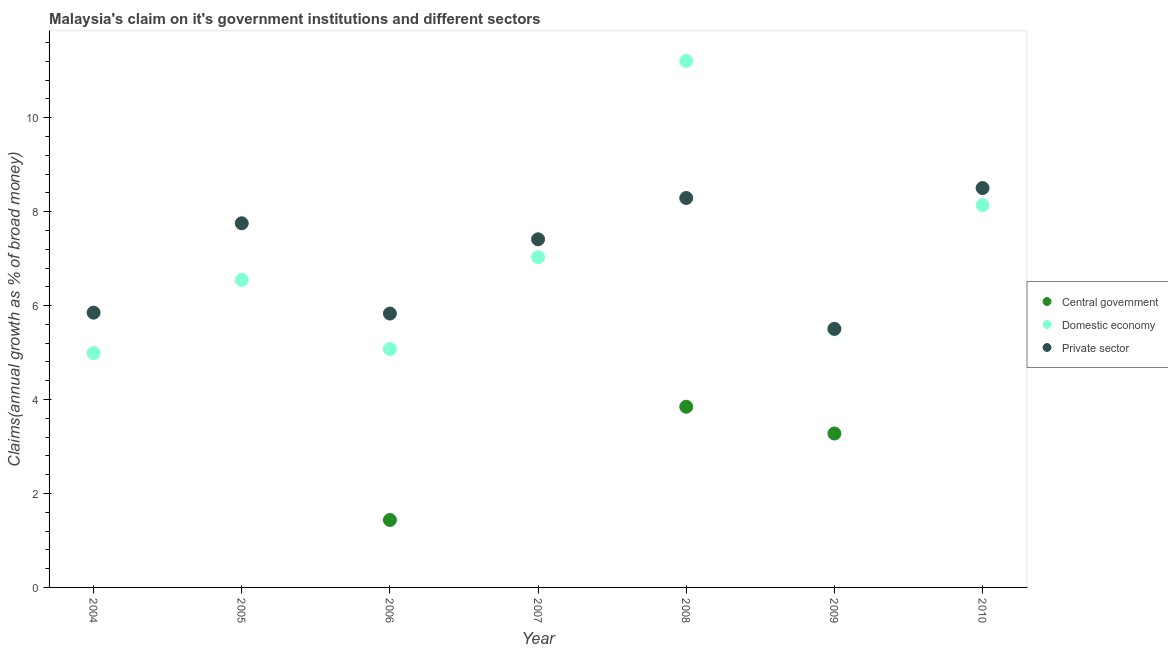How many different coloured dotlines are there?
Make the answer very short. 3. What is the percentage of claim on the central government in 2006?
Provide a short and direct response. 1.44. Across all years, what is the maximum percentage of claim on the domestic economy?
Ensure brevity in your answer.  11.21. Across all years, what is the minimum percentage of claim on the domestic economy?
Offer a terse response. 4.99. In which year was the percentage of claim on the private sector maximum?
Give a very brief answer. 2010. What is the total percentage of claim on the domestic economy in the graph?
Offer a very short reply. 48.48. What is the difference between the percentage of claim on the domestic economy in 2004 and that in 2006?
Give a very brief answer. -0.09. What is the difference between the percentage of claim on the central government in 2010 and the percentage of claim on the private sector in 2006?
Ensure brevity in your answer.  -5.83. What is the average percentage of claim on the central government per year?
Provide a short and direct response. 1.22. In the year 2006, what is the difference between the percentage of claim on the private sector and percentage of claim on the domestic economy?
Provide a succinct answer. 0.76. In how many years, is the percentage of claim on the private sector greater than 4.8 %?
Offer a terse response. 7. What is the ratio of the percentage of claim on the private sector in 2006 to that in 2008?
Offer a terse response. 0.7. What is the difference between the highest and the second highest percentage of claim on the private sector?
Make the answer very short. 0.21. What is the difference between the highest and the lowest percentage of claim on the private sector?
Give a very brief answer. 3. How many dotlines are there?
Your answer should be compact. 3. Does the graph contain grids?
Provide a succinct answer. No. How many legend labels are there?
Keep it short and to the point. 3. How are the legend labels stacked?
Your response must be concise. Vertical. What is the title of the graph?
Your answer should be compact. Malaysia's claim on it's government institutions and different sectors. What is the label or title of the X-axis?
Keep it short and to the point. Year. What is the label or title of the Y-axis?
Keep it short and to the point. Claims(annual growth as % of broad money). What is the Claims(annual growth as % of broad money) of Central government in 2004?
Your response must be concise. 0. What is the Claims(annual growth as % of broad money) in Domestic economy in 2004?
Your answer should be compact. 4.99. What is the Claims(annual growth as % of broad money) in Private sector in 2004?
Provide a short and direct response. 5.85. What is the Claims(annual growth as % of broad money) of Central government in 2005?
Offer a very short reply. 0. What is the Claims(annual growth as % of broad money) in Domestic economy in 2005?
Your answer should be compact. 6.55. What is the Claims(annual growth as % of broad money) in Private sector in 2005?
Give a very brief answer. 7.75. What is the Claims(annual growth as % of broad money) of Central government in 2006?
Give a very brief answer. 1.44. What is the Claims(annual growth as % of broad money) of Domestic economy in 2006?
Keep it short and to the point. 5.07. What is the Claims(annual growth as % of broad money) of Private sector in 2006?
Provide a short and direct response. 5.83. What is the Claims(annual growth as % of broad money) of Domestic economy in 2007?
Provide a short and direct response. 7.03. What is the Claims(annual growth as % of broad money) of Private sector in 2007?
Make the answer very short. 7.41. What is the Claims(annual growth as % of broad money) of Central government in 2008?
Provide a short and direct response. 3.85. What is the Claims(annual growth as % of broad money) in Domestic economy in 2008?
Your response must be concise. 11.21. What is the Claims(annual growth as % of broad money) in Private sector in 2008?
Offer a very short reply. 8.29. What is the Claims(annual growth as % of broad money) of Central government in 2009?
Make the answer very short. 3.28. What is the Claims(annual growth as % of broad money) in Domestic economy in 2009?
Provide a succinct answer. 5.49. What is the Claims(annual growth as % of broad money) in Private sector in 2009?
Offer a terse response. 5.5. What is the Claims(annual growth as % of broad money) in Central government in 2010?
Your response must be concise. 0. What is the Claims(annual growth as % of broad money) in Domestic economy in 2010?
Keep it short and to the point. 8.14. What is the Claims(annual growth as % of broad money) in Private sector in 2010?
Offer a terse response. 8.5. Across all years, what is the maximum Claims(annual growth as % of broad money) of Central government?
Provide a short and direct response. 3.85. Across all years, what is the maximum Claims(annual growth as % of broad money) in Domestic economy?
Offer a very short reply. 11.21. Across all years, what is the maximum Claims(annual growth as % of broad money) in Private sector?
Provide a short and direct response. 8.5. Across all years, what is the minimum Claims(annual growth as % of broad money) of Central government?
Keep it short and to the point. 0. Across all years, what is the minimum Claims(annual growth as % of broad money) in Domestic economy?
Your response must be concise. 4.99. Across all years, what is the minimum Claims(annual growth as % of broad money) of Private sector?
Give a very brief answer. 5.5. What is the total Claims(annual growth as % of broad money) of Central government in the graph?
Provide a succinct answer. 8.56. What is the total Claims(annual growth as % of broad money) in Domestic economy in the graph?
Give a very brief answer. 48.48. What is the total Claims(annual growth as % of broad money) of Private sector in the graph?
Make the answer very short. 49.14. What is the difference between the Claims(annual growth as % of broad money) of Domestic economy in 2004 and that in 2005?
Give a very brief answer. -1.56. What is the difference between the Claims(annual growth as % of broad money) in Private sector in 2004 and that in 2005?
Give a very brief answer. -1.9. What is the difference between the Claims(annual growth as % of broad money) of Domestic economy in 2004 and that in 2006?
Your response must be concise. -0.09. What is the difference between the Claims(annual growth as % of broad money) of Private sector in 2004 and that in 2006?
Your answer should be very brief. 0.02. What is the difference between the Claims(annual growth as % of broad money) of Domestic economy in 2004 and that in 2007?
Offer a very short reply. -2.04. What is the difference between the Claims(annual growth as % of broad money) of Private sector in 2004 and that in 2007?
Your answer should be compact. -1.56. What is the difference between the Claims(annual growth as % of broad money) in Domestic economy in 2004 and that in 2008?
Your response must be concise. -6.22. What is the difference between the Claims(annual growth as % of broad money) of Private sector in 2004 and that in 2008?
Offer a very short reply. -2.44. What is the difference between the Claims(annual growth as % of broad money) of Domestic economy in 2004 and that in 2009?
Offer a terse response. -0.51. What is the difference between the Claims(annual growth as % of broad money) of Private sector in 2004 and that in 2009?
Ensure brevity in your answer.  0.34. What is the difference between the Claims(annual growth as % of broad money) of Domestic economy in 2004 and that in 2010?
Offer a very short reply. -3.15. What is the difference between the Claims(annual growth as % of broad money) in Private sector in 2004 and that in 2010?
Offer a very short reply. -2.65. What is the difference between the Claims(annual growth as % of broad money) of Domestic economy in 2005 and that in 2006?
Make the answer very short. 1.47. What is the difference between the Claims(annual growth as % of broad money) in Private sector in 2005 and that in 2006?
Give a very brief answer. 1.92. What is the difference between the Claims(annual growth as % of broad money) in Domestic economy in 2005 and that in 2007?
Offer a terse response. -0.48. What is the difference between the Claims(annual growth as % of broad money) in Private sector in 2005 and that in 2007?
Your answer should be compact. 0.34. What is the difference between the Claims(annual growth as % of broad money) in Domestic economy in 2005 and that in 2008?
Your response must be concise. -4.66. What is the difference between the Claims(annual growth as % of broad money) of Private sector in 2005 and that in 2008?
Your answer should be very brief. -0.54. What is the difference between the Claims(annual growth as % of broad money) of Domestic economy in 2005 and that in 2009?
Your response must be concise. 1.06. What is the difference between the Claims(annual growth as % of broad money) of Private sector in 2005 and that in 2009?
Provide a succinct answer. 2.25. What is the difference between the Claims(annual growth as % of broad money) of Domestic economy in 2005 and that in 2010?
Provide a short and direct response. -1.59. What is the difference between the Claims(annual growth as % of broad money) of Private sector in 2005 and that in 2010?
Offer a very short reply. -0.75. What is the difference between the Claims(annual growth as % of broad money) in Domestic economy in 2006 and that in 2007?
Provide a succinct answer. -1.96. What is the difference between the Claims(annual growth as % of broad money) in Private sector in 2006 and that in 2007?
Keep it short and to the point. -1.58. What is the difference between the Claims(annual growth as % of broad money) in Central government in 2006 and that in 2008?
Provide a short and direct response. -2.41. What is the difference between the Claims(annual growth as % of broad money) of Domestic economy in 2006 and that in 2008?
Keep it short and to the point. -6.13. What is the difference between the Claims(annual growth as % of broad money) of Private sector in 2006 and that in 2008?
Give a very brief answer. -2.46. What is the difference between the Claims(annual growth as % of broad money) of Central government in 2006 and that in 2009?
Your answer should be compact. -1.84. What is the difference between the Claims(annual growth as % of broad money) of Domestic economy in 2006 and that in 2009?
Offer a terse response. -0.42. What is the difference between the Claims(annual growth as % of broad money) of Private sector in 2006 and that in 2009?
Your answer should be compact. 0.33. What is the difference between the Claims(annual growth as % of broad money) of Domestic economy in 2006 and that in 2010?
Your response must be concise. -3.06. What is the difference between the Claims(annual growth as % of broad money) of Private sector in 2006 and that in 2010?
Give a very brief answer. -2.67. What is the difference between the Claims(annual growth as % of broad money) in Domestic economy in 2007 and that in 2008?
Your answer should be very brief. -4.18. What is the difference between the Claims(annual growth as % of broad money) in Private sector in 2007 and that in 2008?
Give a very brief answer. -0.88. What is the difference between the Claims(annual growth as % of broad money) of Domestic economy in 2007 and that in 2009?
Provide a succinct answer. 1.54. What is the difference between the Claims(annual growth as % of broad money) of Private sector in 2007 and that in 2009?
Offer a terse response. 1.91. What is the difference between the Claims(annual growth as % of broad money) in Domestic economy in 2007 and that in 2010?
Your response must be concise. -1.11. What is the difference between the Claims(annual growth as % of broad money) of Private sector in 2007 and that in 2010?
Provide a short and direct response. -1.09. What is the difference between the Claims(annual growth as % of broad money) in Central government in 2008 and that in 2009?
Give a very brief answer. 0.57. What is the difference between the Claims(annual growth as % of broad money) in Domestic economy in 2008 and that in 2009?
Provide a succinct answer. 5.72. What is the difference between the Claims(annual growth as % of broad money) of Private sector in 2008 and that in 2009?
Provide a succinct answer. 2.79. What is the difference between the Claims(annual growth as % of broad money) of Domestic economy in 2008 and that in 2010?
Provide a short and direct response. 3.07. What is the difference between the Claims(annual growth as % of broad money) of Private sector in 2008 and that in 2010?
Offer a terse response. -0.21. What is the difference between the Claims(annual growth as % of broad money) in Domestic economy in 2009 and that in 2010?
Ensure brevity in your answer.  -2.64. What is the difference between the Claims(annual growth as % of broad money) of Private sector in 2009 and that in 2010?
Your response must be concise. -3. What is the difference between the Claims(annual growth as % of broad money) in Domestic economy in 2004 and the Claims(annual growth as % of broad money) in Private sector in 2005?
Ensure brevity in your answer.  -2.77. What is the difference between the Claims(annual growth as % of broad money) of Domestic economy in 2004 and the Claims(annual growth as % of broad money) of Private sector in 2006?
Ensure brevity in your answer.  -0.84. What is the difference between the Claims(annual growth as % of broad money) in Domestic economy in 2004 and the Claims(annual growth as % of broad money) in Private sector in 2007?
Your response must be concise. -2.42. What is the difference between the Claims(annual growth as % of broad money) of Domestic economy in 2004 and the Claims(annual growth as % of broad money) of Private sector in 2008?
Ensure brevity in your answer.  -3.3. What is the difference between the Claims(annual growth as % of broad money) of Domestic economy in 2004 and the Claims(annual growth as % of broad money) of Private sector in 2009?
Ensure brevity in your answer.  -0.52. What is the difference between the Claims(annual growth as % of broad money) in Domestic economy in 2004 and the Claims(annual growth as % of broad money) in Private sector in 2010?
Your answer should be very brief. -3.51. What is the difference between the Claims(annual growth as % of broad money) in Domestic economy in 2005 and the Claims(annual growth as % of broad money) in Private sector in 2006?
Offer a terse response. 0.72. What is the difference between the Claims(annual growth as % of broad money) in Domestic economy in 2005 and the Claims(annual growth as % of broad money) in Private sector in 2007?
Give a very brief answer. -0.86. What is the difference between the Claims(annual growth as % of broad money) in Domestic economy in 2005 and the Claims(annual growth as % of broad money) in Private sector in 2008?
Make the answer very short. -1.74. What is the difference between the Claims(annual growth as % of broad money) in Domestic economy in 2005 and the Claims(annual growth as % of broad money) in Private sector in 2009?
Provide a succinct answer. 1.04. What is the difference between the Claims(annual growth as % of broad money) of Domestic economy in 2005 and the Claims(annual growth as % of broad money) of Private sector in 2010?
Ensure brevity in your answer.  -1.95. What is the difference between the Claims(annual growth as % of broad money) of Central government in 2006 and the Claims(annual growth as % of broad money) of Domestic economy in 2007?
Ensure brevity in your answer.  -5.59. What is the difference between the Claims(annual growth as % of broad money) of Central government in 2006 and the Claims(annual growth as % of broad money) of Private sector in 2007?
Keep it short and to the point. -5.98. What is the difference between the Claims(annual growth as % of broad money) in Domestic economy in 2006 and the Claims(annual growth as % of broad money) in Private sector in 2007?
Make the answer very short. -2.34. What is the difference between the Claims(annual growth as % of broad money) of Central government in 2006 and the Claims(annual growth as % of broad money) of Domestic economy in 2008?
Offer a terse response. -9.77. What is the difference between the Claims(annual growth as % of broad money) in Central government in 2006 and the Claims(annual growth as % of broad money) in Private sector in 2008?
Provide a succinct answer. -6.85. What is the difference between the Claims(annual growth as % of broad money) of Domestic economy in 2006 and the Claims(annual growth as % of broad money) of Private sector in 2008?
Your response must be concise. -3.22. What is the difference between the Claims(annual growth as % of broad money) in Central government in 2006 and the Claims(annual growth as % of broad money) in Domestic economy in 2009?
Offer a very short reply. -4.06. What is the difference between the Claims(annual growth as % of broad money) in Central government in 2006 and the Claims(annual growth as % of broad money) in Private sector in 2009?
Ensure brevity in your answer.  -4.07. What is the difference between the Claims(annual growth as % of broad money) in Domestic economy in 2006 and the Claims(annual growth as % of broad money) in Private sector in 2009?
Keep it short and to the point. -0.43. What is the difference between the Claims(annual growth as % of broad money) in Central government in 2006 and the Claims(annual growth as % of broad money) in Domestic economy in 2010?
Make the answer very short. -6.7. What is the difference between the Claims(annual growth as % of broad money) of Central government in 2006 and the Claims(annual growth as % of broad money) of Private sector in 2010?
Provide a short and direct response. -7.07. What is the difference between the Claims(annual growth as % of broad money) in Domestic economy in 2006 and the Claims(annual growth as % of broad money) in Private sector in 2010?
Keep it short and to the point. -3.43. What is the difference between the Claims(annual growth as % of broad money) in Domestic economy in 2007 and the Claims(annual growth as % of broad money) in Private sector in 2008?
Keep it short and to the point. -1.26. What is the difference between the Claims(annual growth as % of broad money) of Domestic economy in 2007 and the Claims(annual growth as % of broad money) of Private sector in 2009?
Provide a short and direct response. 1.53. What is the difference between the Claims(annual growth as % of broad money) of Domestic economy in 2007 and the Claims(annual growth as % of broad money) of Private sector in 2010?
Keep it short and to the point. -1.47. What is the difference between the Claims(annual growth as % of broad money) in Central government in 2008 and the Claims(annual growth as % of broad money) in Domestic economy in 2009?
Ensure brevity in your answer.  -1.65. What is the difference between the Claims(annual growth as % of broad money) of Central government in 2008 and the Claims(annual growth as % of broad money) of Private sector in 2009?
Your answer should be compact. -1.66. What is the difference between the Claims(annual growth as % of broad money) of Domestic economy in 2008 and the Claims(annual growth as % of broad money) of Private sector in 2009?
Your answer should be compact. 5.7. What is the difference between the Claims(annual growth as % of broad money) in Central government in 2008 and the Claims(annual growth as % of broad money) in Domestic economy in 2010?
Ensure brevity in your answer.  -4.29. What is the difference between the Claims(annual growth as % of broad money) of Central government in 2008 and the Claims(annual growth as % of broad money) of Private sector in 2010?
Offer a very short reply. -4.66. What is the difference between the Claims(annual growth as % of broad money) in Domestic economy in 2008 and the Claims(annual growth as % of broad money) in Private sector in 2010?
Offer a terse response. 2.71. What is the difference between the Claims(annual growth as % of broad money) of Central government in 2009 and the Claims(annual growth as % of broad money) of Domestic economy in 2010?
Your answer should be compact. -4.86. What is the difference between the Claims(annual growth as % of broad money) of Central government in 2009 and the Claims(annual growth as % of broad money) of Private sector in 2010?
Your answer should be very brief. -5.23. What is the difference between the Claims(annual growth as % of broad money) in Domestic economy in 2009 and the Claims(annual growth as % of broad money) in Private sector in 2010?
Ensure brevity in your answer.  -3.01. What is the average Claims(annual growth as % of broad money) of Central government per year?
Ensure brevity in your answer.  1.22. What is the average Claims(annual growth as % of broad money) in Domestic economy per year?
Your answer should be compact. 6.93. What is the average Claims(annual growth as % of broad money) of Private sector per year?
Ensure brevity in your answer.  7.02. In the year 2004, what is the difference between the Claims(annual growth as % of broad money) of Domestic economy and Claims(annual growth as % of broad money) of Private sector?
Ensure brevity in your answer.  -0.86. In the year 2005, what is the difference between the Claims(annual growth as % of broad money) in Domestic economy and Claims(annual growth as % of broad money) in Private sector?
Your response must be concise. -1.2. In the year 2006, what is the difference between the Claims(annual growth as % of broad money) of Central government and Claims(annual growth as % of broad money) of Domestic economy?
Offer a terse response. -3.64. In the year 2006, what is the difference between the Claims(annual growth as % of broad money) in Central government and Claims(annual growth as % of broad money) in Private sector?
Your answer should be very brief. -4.39. In the year 2006, what is the difference between the Claims(annual growth as % of broad money) in Domestic economy and Claims(annual growth as % of broad money) in Private sector?
Ensure brevity in your answer.  -0.76. In the year 2007, what is the difference between the Claims(annual growth as % of broad money) in Domestic economy and Claims(annual growth as % of broad money) in Private sector?
Keep it short and to the point. -0.38. In the year 2008, what is the difference between the Claims(annual growth as % of broad money) in Central government and Claims(annual growth as % of broad money) in Domestic economy?
Your response must be concise. -7.36. In the year 2008, what is the difference between the Claims(annual growth as % of broad money) in Central government and Claims(annual growth as % of broad money) in Private sector?
Make the answer very short. -4.44. In the year 2008, what is the difference between the Claims(annual growth as % of broad money) of Domestic economy and Claims(annual growth as % of broad money) of Private sector?
Your answer should be very brief. 2.92. In the year 2009, what is the difference between the Claims(annual growth as % of broad money) in Central government and Claims(annual growth as % of broad money) in Domestic economy?
Your answer should be compact. -2.22. In the year 2009, what is the difference between the Claims(annual growth as % of broad money) in Central government and Claims(annual growth as % of broad money) in Private sector?
Your response must be concise. -2.23. In the year 2009, what is the difference between the Claims(annual growth as % of broad money) of Domestic economy and Claims(annual growth as % of broad money) of Private sector?
Your answer should be very brief. -0.01. In the year 2010, what is the difference between the Claims(annual growth as % of broad money) in Domestic economy and Claims(annual growth as % of broad money) in Private sector?
Make the answer very short. -0.36. What is the ratio of the Claims(annual growth as % of broad money) of Domestic economy in 2004 to that in 2005?
Make the answer very short. 0.76. What is the ratio of the Claims(annual growth as % of broad money) of Private sector in 2004 to that in 2005?
Your response must be concise. 0.75. What is the ratio of the Claims(annual growth as % of broad money) of Domestic economy in 2004 to that in 2006?
Provide a succinct answer. 0.98. What is the ratio of the Claims(annual growth as % of broad money) in Domestic economy in 2004 to that in 2007?
Ensure brevity in your answer.  0.71. What is the ratio of the Claims(annual growth as % of broad money) in Private sector in 2004 to that in 2007?
Make the answer very short. 0.79. What is the ratio of the Claims(annual growth as % of broad money) of Domestic economy in 2004 to that in 2008?
Keep it short and to the point. 0.45. What is the ratio of the Claims(annual growth as % of broad money) of Private sector in 2004 to that in 2008?
Provide a short and direct response. 0.71. What is the ratio of the Claims(annual growth as % of broad money) of Domestic economy in 2004 to that in 2009?
Ensure brevity in your answer.  0.91. What is the ratio of the Claims(annual growth as % of broad money) in Private sector in 2004 to that in 2009?
Your response must be concise. 1.06. What is the ratio of the Claims(annual growth as % of broad money) in Domestic economy in 2004 to that in 2010?
Ensure brevity in your answer.  0.61. What is the ratio of the Claims(annual growth as % of broad money) of Private sector in 2004 to that in 2010?
Provide a succinct answer. 0.69. What is the ratio of the Claims(annual growth as % of broad money) of Domestic economy in 2005 to that in 2006?
Make the answer very short. 1.29. What is the ratio of the Claims(annual growth as % of broad money) in Private sector in 2005 to that in 2006?
Offer a terse response. 1.33. What is the ratio of the Claims(annual growth as % of broad money) in Domestic economy in 2005 to that in 2007?
Make the answer very short. 0.93. What is the ratio of the Claims(annual growth as % of broad money) of Private sector in 2005 to that in 2007?
Give a very brief answer. 1.05. What is the ratio of the Claims(annual growth as % of broad money) of Domestic economy in 2005 to that in 2008?
Keep it short and to the point. 0.58. What is the ratio of the Claims(annual growth as % of broad money) of Private sector in 2005 to that in 2008?
Ensure brevity in your answer.  0.94. What is the ratio of the Claims(annual growth as % of broad money) in Domestic economy in 2005 to that in 2009?
Your answer should be compact. 1.19. What is the ratio of the Claims(annual growth as % of broad money) of Private sector in 2005 to that in 2009?
Your answer should be compact. 1.41. What is the ratio of the Claims(annual growth as % of broad money) in Domestic economy in 2005 to that in 2010?
Provide a short and direct response. 0.8. What is the ratio of the Claims(annual growth as % of broad money) of Private sector in 2005 to that in 2010?
Your answer should be compact. 0.91. What is the ratio of the Claims(annual growth as % of broad money) in Domestic economy in 2006 to that in 2007?
Ensure brevity in your answer.  0.72. What is the ratio of the Claims(annual growth as % of broad money) in Private sector in 2006 to that in 2007?
Offer a very short reply. 0.79. What is the ratio of the Claims(annual growth as % of broad money) in Central government in 2006 to that in 2008?
Give a very brief answer. 0.37. What is the ratio of the Claims(annual growth as % of broad money) in Domestic economy in 2006 to that in 2008?
Your response must be concise. 0.45. What is the ratio of the Claims(annual growth as % of broad money) of Private sector in 2006 to that in 2008?
Your answer should be very brief. 0.7. What is the ratio of the Claims(annual growth as % of broad money) of Central government in 2006 to that in 2009?
Provide a succinct answer. 0.44. What is the ratio of the Claims(annual growth as % of broad money) in Domestic economy in 2006 to that in 2009?
Your response must be concise. 0.92. What is the ratio of the Claims(annual growth as % of broad money) in Private sector in 2006 to that in 2009?
Offer a terse response. 1.06. What is the ratio of the Claims(annual growth as % of broad money) in Domestic economy in 2006 to that in 2010?
Offer a very short reply. 0.62. What is the ratio of the Claims(annual growth as % of broad money) in Private sector in 2006 to that in 2010?
Offer a very short reply. 0.69. What is the ratio of the Claims(annual growth as % of broad money) of Domestic economy in 2007 to that in 2008?
Provide a short and direct response. 0.63. What is the ratio of the Claims(annual growth as % of broad money) of Private sector in 2007 to that in 2008?
Your answer should be very brief. 0.89. What is the ratio of the Claims(annual growth as % of broad money) in Domestic economy in 2007 to that in 2009?
Keep it short and to the point. 1.28. What is the ratio of the Claims(annual growth as % of broad money) in Private sector in 2007 to that in 2009?
Provide a succinct answer. 1.35. What is the ratio of the Claims(annual growth as % of broad money) in Domestic economy in 2007 to that in 2010?
Make the answer very short. 0.86. What is the ratio of the Claims(annual growth as % of broad money) in Private sector in 2007 to that in 2010?
Your answer should be very brief. 0.87. What is the ratio of the Claims(annual growth as % of broad money) of Central government in 2008 to that in 2009?
Provide a short and direct response. 1.17. What is the ratio of the Claims(annual growth as % of broad money) of Domestic economy in 2008 to that in 2009?
Offer a terse response. 2.04. What is the ratio of the Claims(annual growth as % of broad money) in Private sector in 2008 to that in 2009?
Your answer should be compact. 1.51. What is the ratio of the Claims(annual growth as % of broad money) of Domestic economy in 2008 to that in 2010?
Give a very brief answer. 1.38. What is the ratio of the Claims(annual growth as % of broad money) of Private sector in 2008 to that in 2010?
Ensure brevity in your answer.  0.98. What is the ratio of the Claims(annual growth as % of broad money) of Domestic economy in 2009 to that in 2010?
Give a very brief answer. 0.68. What is the ratio of the Claims(annual growth as % of broad money) of Private sector in 2009 to that in 2010?
Your answer should be very brief. 0.65. What is the difference between the highest and the second highest Claims(annual growth as % of broad money) in Central government?
Offer a terse response. 0.57. What is the difference between the highest and the second highest Claims(annual growth as % of broad money) of Domestic economy?
Your answer should be very brief. 3.07. What is the difference between the highest and the second highest Claims(annual growth as % of broad money) of Private sector?
Your answer should be compact. 0.21. What is the difference between the highest and the lowest Claims(annual growth as % of broad money) of Central government?
Make the answer very short. 3.85. What is the difference between the highest and the lowest Claims(annual growth as % of broad money) in Domestic economy?
Your response must be concise. 6.22. What is the difference between the highest and the lowest Claims(annual growth as % of broad money) in Private sector?
Your answer should be compact. 3. 